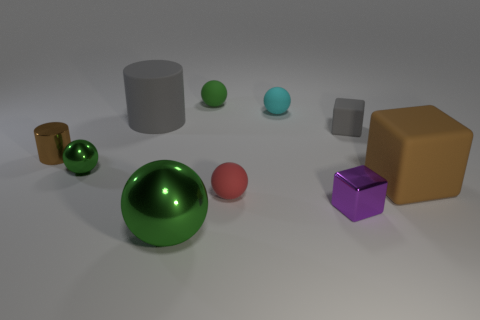How many green balls must be subtracted to get 1 green balls? 2 Subtract all brown cubes. How many green balls are left? 3 Subtract all cyan balls. How many balls are left? 4 Subtract all large green balls. How many balls are left? 4 Subtract all yellow spheres. Subtract all brown blocks. How many spheres are left? 5 Subtract all cylinders. How many objects are left? 8 Add 5 large green things. How many large green things are left? 6 Add 1 purple matte spheres. How many purple matte spheres exist? 1 Subtract 1 gray cubes. How many objects are left? 9 Subtract all gray rubber cylinders. Subtract all tiny purple objects. How many objects are left? 8 